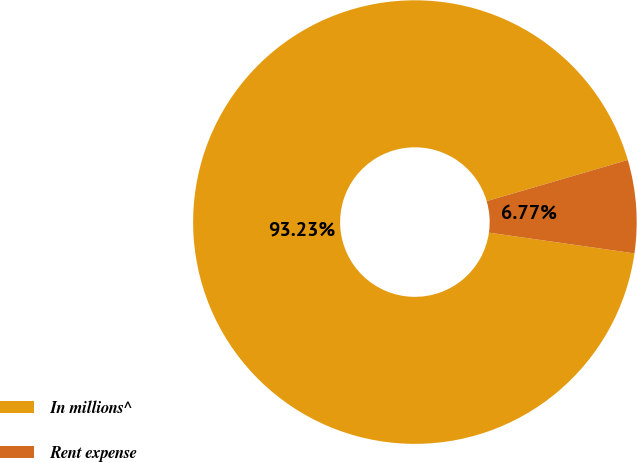<chart> <loc_0><loc_0><loc_500><loc_500><pie_chart><fcel>In millions^<fcel>Rent expense<nl><fcel>93.23%<fcel>6.77%<nl></chart> 